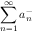Convert formula to latex. <formula><loc_0><loc_0><loc_500><loc_500>\sum _ { n = 1 } ^ { \infty } a _ { n } ^ { - }</formula> 